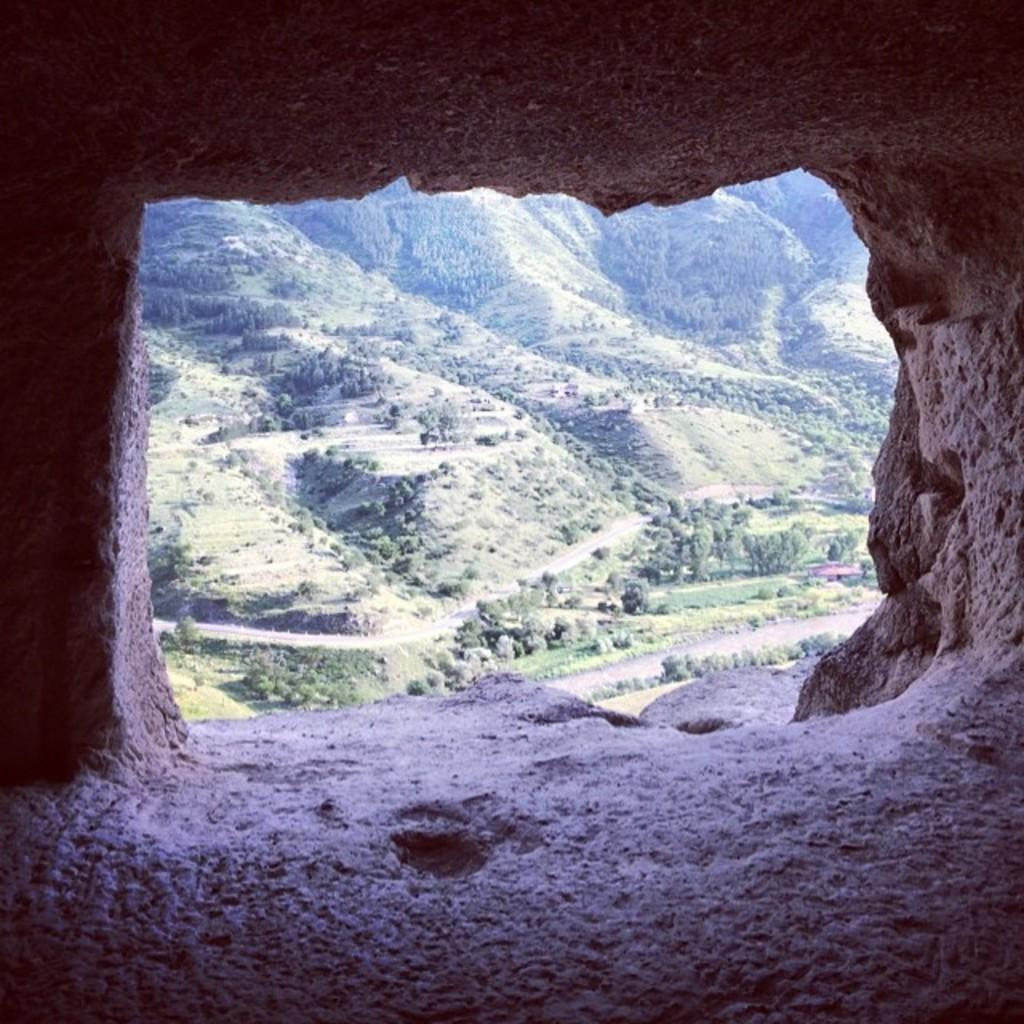Where was the image taken from? The image was taken from inside a cave. What can be seen in the distance in the image? Hills are visible in the image. What type of vegetation is present on the hills? The hills have plants and trees on them. Reasoning: Let' Let's think step by step in order to produce the conversation. We start by identifying the location from where the image was taken, which is inside a cave. Then, we describe the main subject in the distance, which are the hills. Finally, we mention the type of vegetation present on the hills, which includes plants and trees. Each question is designed to elicit a specific detail about the image that is known from the provided facts. Absurd Question/Answer: Can you see any questions floating in the air in the image? There are no questions visible in the image; it features a view from inside a cave with hills, plants, and trees. Are there any signs of quicksand on the hills in the image? There is no indication of quicksand in the image; it features a view from inside a cave with hills, plants, and trees. --- Facts: 1. There is a person sitting on a bench in the image. 2. The person is reading a book. 3. The bench is located in a park. 4. There are trees in the background of the image. 5. The sky is visible in the image. Absurd Topics: bicycle, parrot, rain Conversation: What is the person in the image doing? The person is sitting on a bench and reading a book. Where is the bench located? The bench is located in a park. What can be seen in the background of the image? There are trees in the background of the image. What is visible at the top of the image? The sky is visible in the image. Reasoning: Let's think step by step in order to produce the conversation. We start by identifying the main subject in the image, which is the person sitting on the bench. Then, we describe what the person is doing, which is reading a book. Next, we mention the location of the bench, 